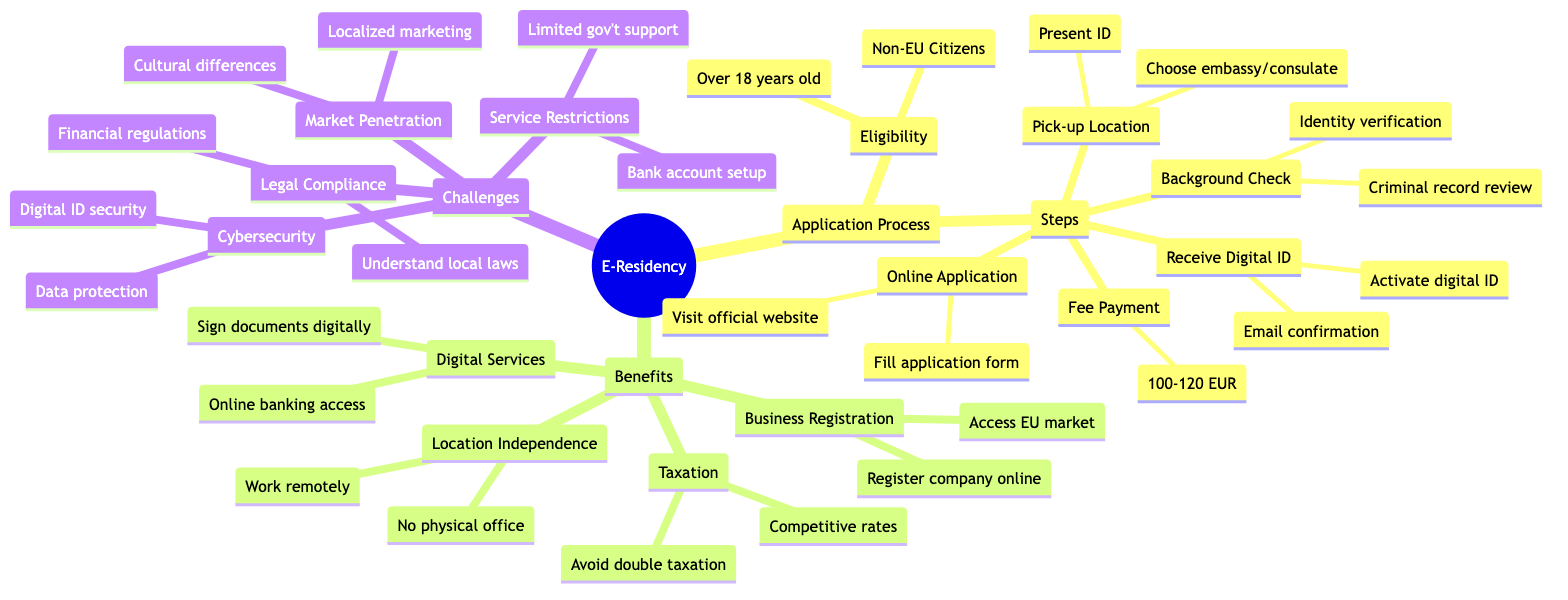What are the eligibility requirements for e-residency? The diagram states that the eligibility requirements include being a non-EU citizen and over 18 years old. These are explicitly listed under the "Eligibility" node.
Answer: Non-EU Citizens, Over 18 years old How many steps are there in the application process? The diagram details five steps in the application process: Online Application, Background Check, Fee Payment, Pick-up Location, and Receive Digital ID. Counting these gives a total of five steps.
Answer: 5 What is the fee range for the e-residency application? The "Fee Payment" node specifically indicates a fee range of 100-120 EUR for the e-residency application. This information is straightforwardly provided in the diagram.
Answer: 100-120 EUR What benefit allows you to sign documents digitally? The diagram mentions "Sign documents digitally" under the "Digital Services" category, indicating that this is a benefit of e-residency that facilitates digital signing.
Answer: Sign documents digitally What challenge is related to understanding local laws? The "Legal Compliance" node includes "Understanding local laws," which indicates that this is a challenge faced by those utilizing e-residency. This specific challenge is noted under the "Challenges" section of the mind map.
Answer: Understanding local laws How does e-residency provide location independence? The diagram explains location independence by noting that e-residency allows individuals to work remotely and that no physical office is required. These two points together indicate that e-residency enhances location independence.
Answer: Work remotely, No physical office required What is a common issue related to service restrictions in e-residency? The "Service Restrictions" section lists "Bank account setup may be challenging" as a common issue faced by e-residents, showing that this is a specific challenge encountered in practice.
Answer: Bank account setup may be challenging Which market-related challenge is highlighted in the diagram? Under "Market Penetration," the diagram lists "Cultural differences" and "Localized marketing" as specific challenges, highlighting these as obstacles for e-residents in adapting to new markets.
Answer: Cultural differences, Localized marketing How can e-residents avoid double taxation? The diagram under "Taxation" states that e-residency helps users "Avoid double taxation," indicating that one of the benefits specifically addresses taxation concerns for e-residents.
Answer: Avoid double taxation 